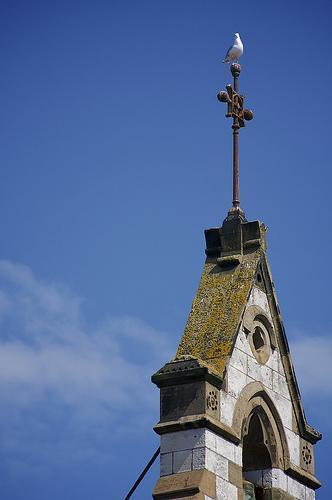How many birds on top of the cross?
Give a very brief answer. 1. 